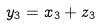<formula> <loc_0><loc_0><loc_500><loc_500>y _ { 3 } = x _ { 3 } + z _ { 3 }</formula> 